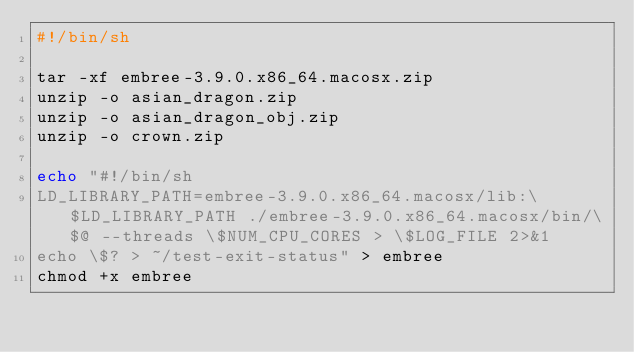Convert code to text. <code><loc_0><loc_0><loc_500><loc_500><_Bash_>#!/bin/sh

tar -xf embree-3.9.0.x86_64.macosx.zip
unzip -o asian_dragon.zip
unzip -o asian_dragon_obj.zip
unzip -o crown.zip

echo "#!/bin/sh
LD_LIBRARY_PATH=embree-3.9.0.x86_64.macosx/lib:\$LD_LIBRARY_PATH ./embree-3.9.0.x86_64.macosx/bin/\$@ --threads \$NUM_CPU_CORES > \$LOG_FILE 2>&1
echo \$? > ~/test-exit-status" > embree
chmod +x embree
</code> 